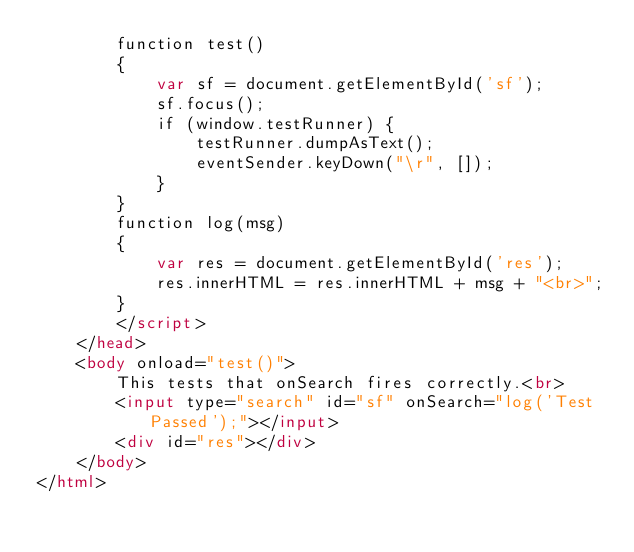<code> <loc_0><loc_0><loc_500><loc_500><_HTML_>        function test()
        {
            var sf = document.getElementById('sf');
            sf.focus();
            if (window.testRunner) {
                testRunner.dumpAsText();
                eventSender.keyDown("\r", []);
            }
        }
        function log(msg)
        {
            var res = document.getElementById('res');
            res.innerHTML = res.innerHTML + msg + "<br>";
        }
        </script>
    </head>
    <body onload="test()">
        This tests that onSearch fires correctly.<br>
        <input type="search" id="sf" onSearch="log('Test Passed');"></input>
        <div id="res"></div>
    </body>
</html>
</code> 